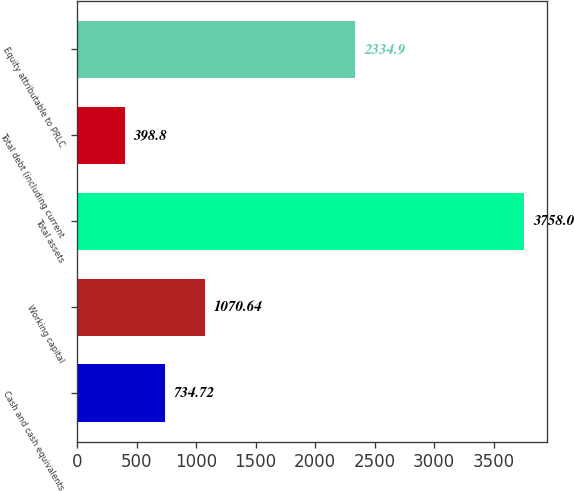<chart> <loc_0><loc_0><loc_500><loc_500><bar_chart><fcel>Cash and cash equivalents<fcel>Working capital<fcel>Total assets<fcel>Total debt (including current<fcel>Equity attributable to PRLC<nl><fcel>734.72<fcel>1070.64<fcel>3758<fcel>398.8<fcel>2334.9<nl></chart> 